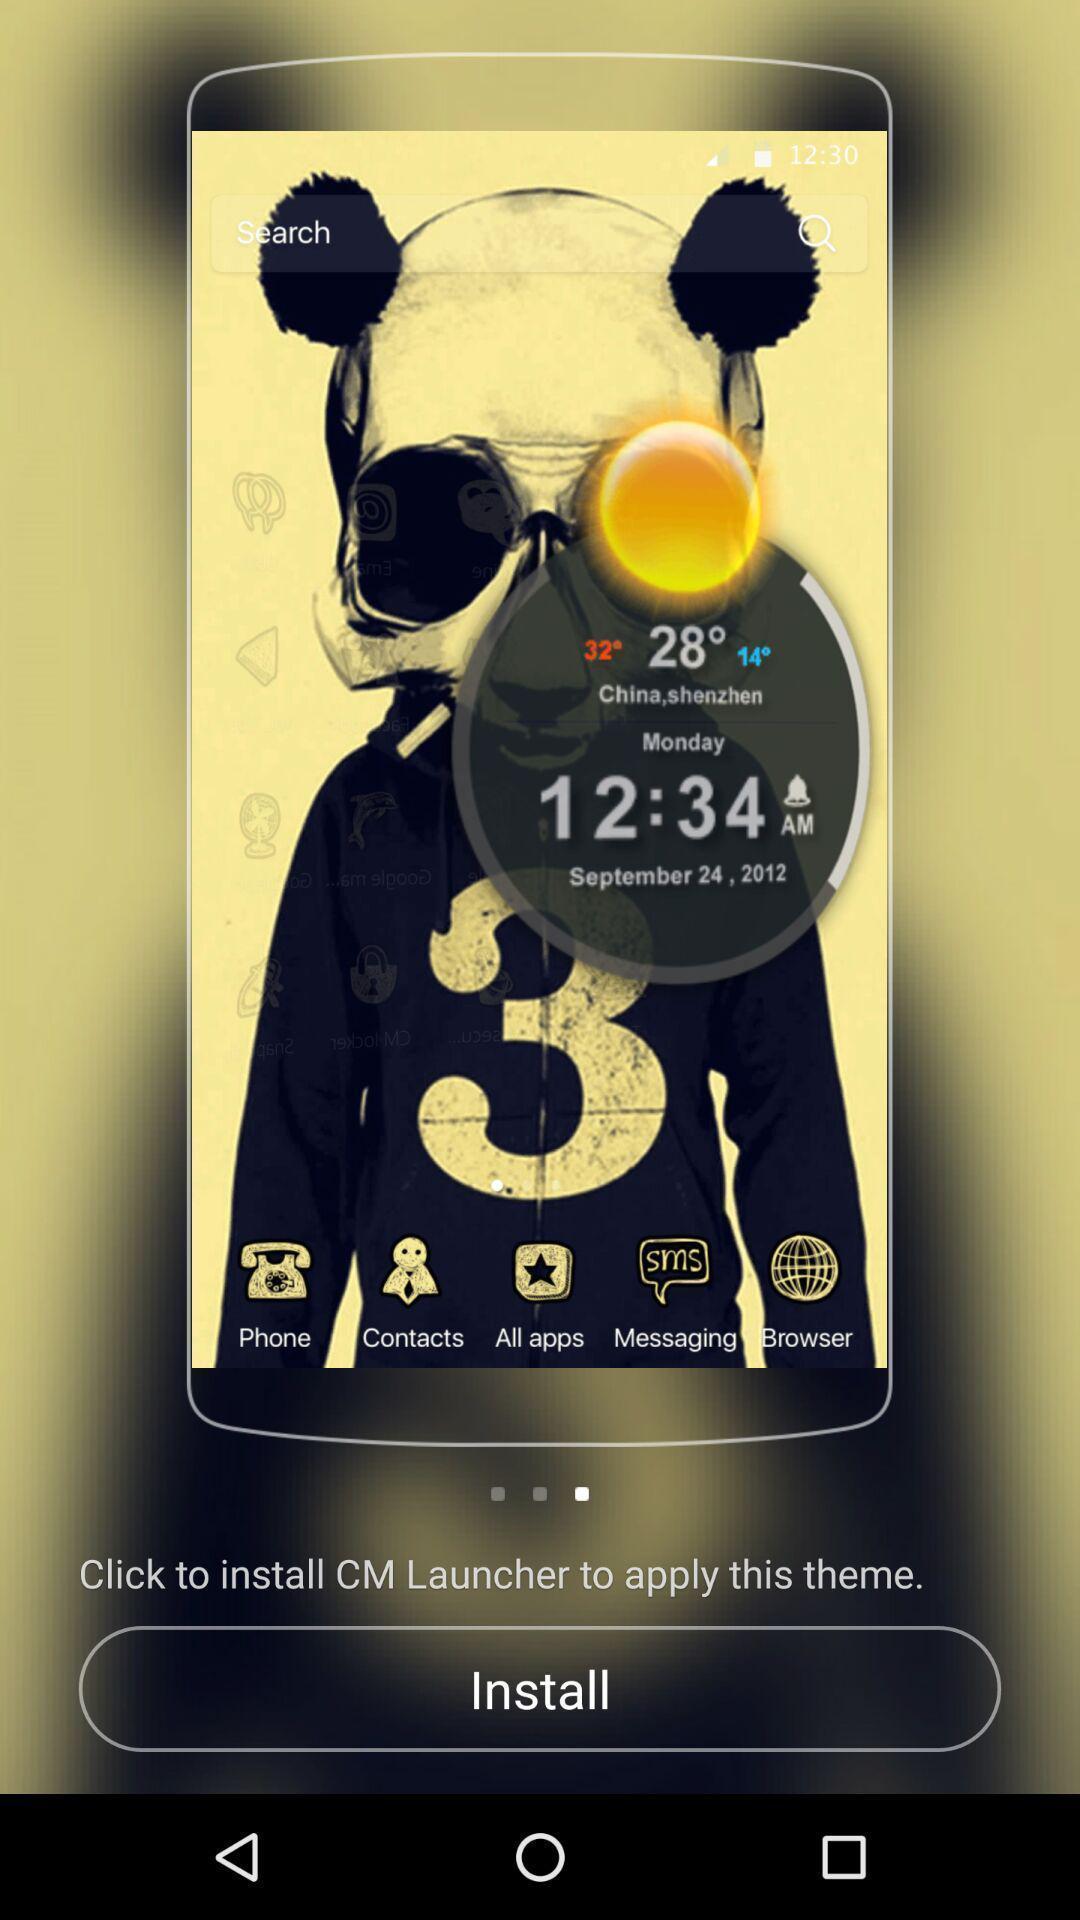Give me a summary of this screen capture. Screen showing the install page of theme launcher. 